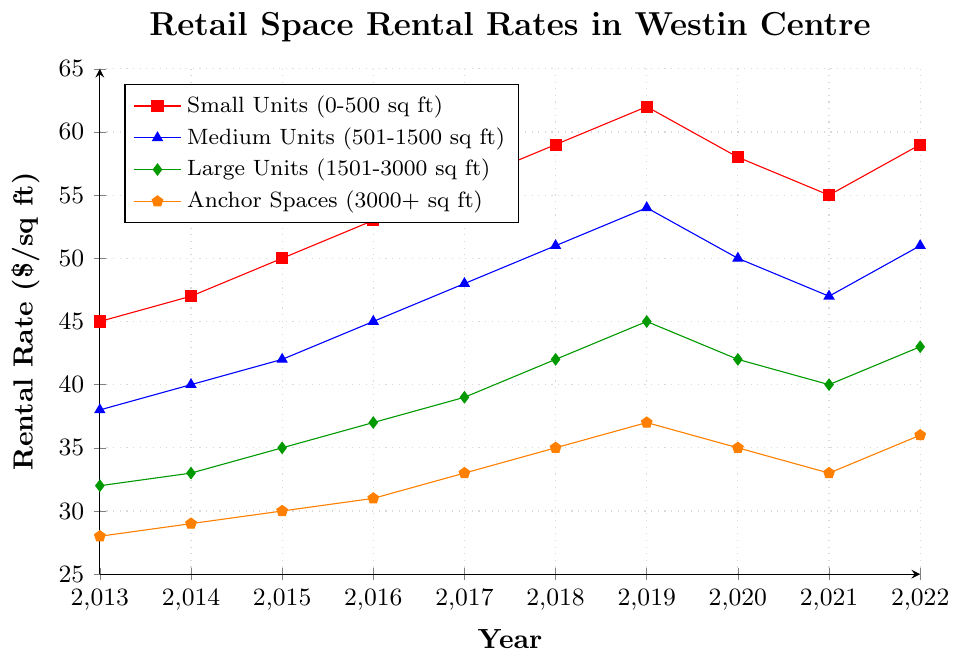What's the rental rate trend for Small Units (0-500 sq ft) from 2013 to 2022? Identify the line representing Small Units (red with square markers). Note how it initially increases from 45 in 2013 to 62 in 2019, dips to 55 by 2021, then rises again to 59 by 2022.
Answer: Generally increasing with a dip and recovery In which year did Medium Units (501-1500 sq ft) have the highest rental rate? Follow the blue line with triangle markers and locate the peak value. The highest rental rate occurred in 2019 at 54.
Answer: 2019 Which unit size category showed the most stable rental rates over the 10 years? Two lines seem relatively stable without sharp rises or falls, but the Anchor Spaces (orange with pentagon markers) show the least variation overall, ranging from 28 to 37.
Answer: Anchor Spaces (3000+ sq ft) Compare the rental rate changes between Small Units (0-500 sq ft) and Large Units (1501-3000 sq ft) from 2019 to 2021. Which category experienced a greater decrease? Identify both lines and calculate the difference for Small Units: 62 (2019) - 55 (2021) = 7, and for Large Units: 45 (2019) - 40 (2021) = 5. Small Units experienced a greater decrease.
Answer: Small Units What is the average rental rate for Anchor Spaces (3000+ sq ft) across all years? Sum the rental rates for Anchor Spaces from 2013 to 2022 and divide by the number of years: (28 + 29 + 30 + 31 + 33 + 35 + 37 + 35 + 33 + 36) / 10 = 32.7
Answer: 32.7 Identify any years where all categories experienced a uniform trend (either all increase or all decrease). Look for years where all lines slope up or down simultaneously. From 2014 to 2015, and from 2016 to 2017, all lines increased.
Answer: 2014-2015 and 2016-2017 What year experienced the largest drop in rental rates for Medium Units (501-1500 sq ft)? The blue line with triangle markers shows a significant drop from 2019 to 2020, falling from 54 to 50.
Answer: 2020 